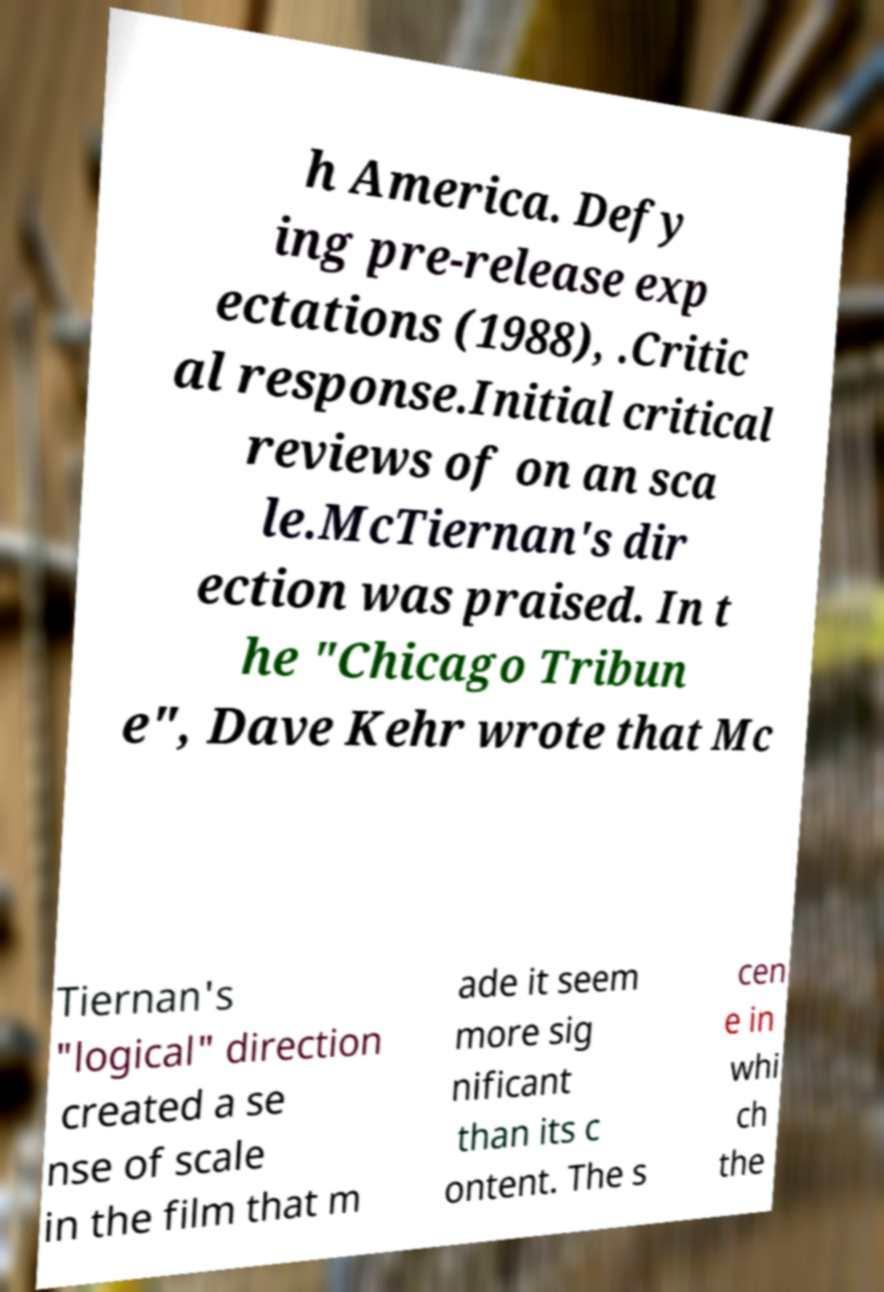Could you assist in decoding the text presented in this image and type it out clearly? h America. Defy ing pre-release exp ectations (1988), .Critic al response.Initial critical reviews of on an sca le.McTiernan's dir ection was praised. In t he "Chicago Tribun e", Dave Kehr wrote that Mc Tiernan's "logical" direction created a se nse of scale in the film that m ade it seem more sig nificant than its c ontent. The s cen e in whi ch the 